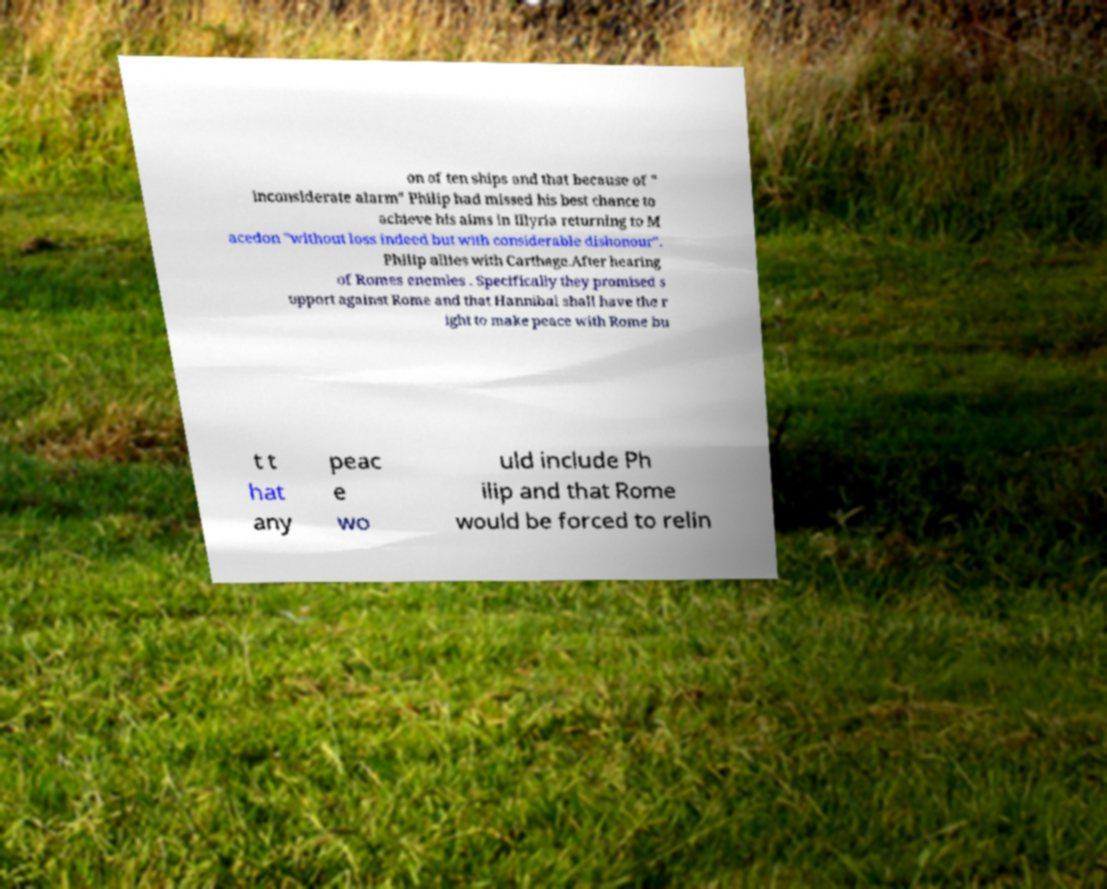What messages or text are displayed in this image? I need them in a readable, typed format. on of ten ships and that because of " inconsiderate alarm" Philip had missed his best chance to achieve his aims in Illyria returning to M acedon "without loss indeed but with considerable dishonour". Philip allies with Carthage.After hearing of Romes enemies . Specifically they promised s upport against Rome and that Hannibal shall have the r ight to make peace with Rome bu t t hat any peac e wo uld include Ph ilip and that Rome would be forced to relin 